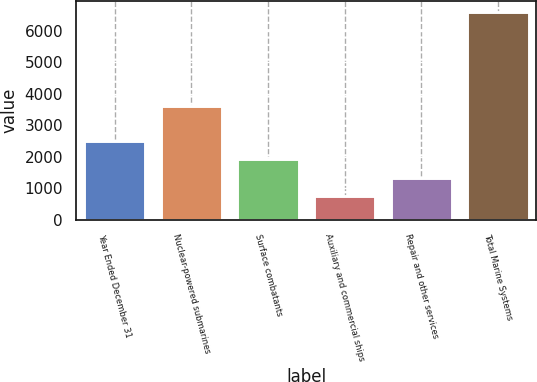Convert chart to OTSL. <chart><loc_0><loc_0><loc_500><loc_500><bar_chart><fcel>Year Ended December 31<fcel>Nuclear-powered submarines<fcel>Surface combatants<fcel>Auxiliary and commercial ships<fcel>Repair and other services<fcel>Total Marine Systems<nl><fcel>2499.8<fcel>3601<fcel>1915.2<fcel>746<fcel>1330.6<fcel>6592<nl></chart> 